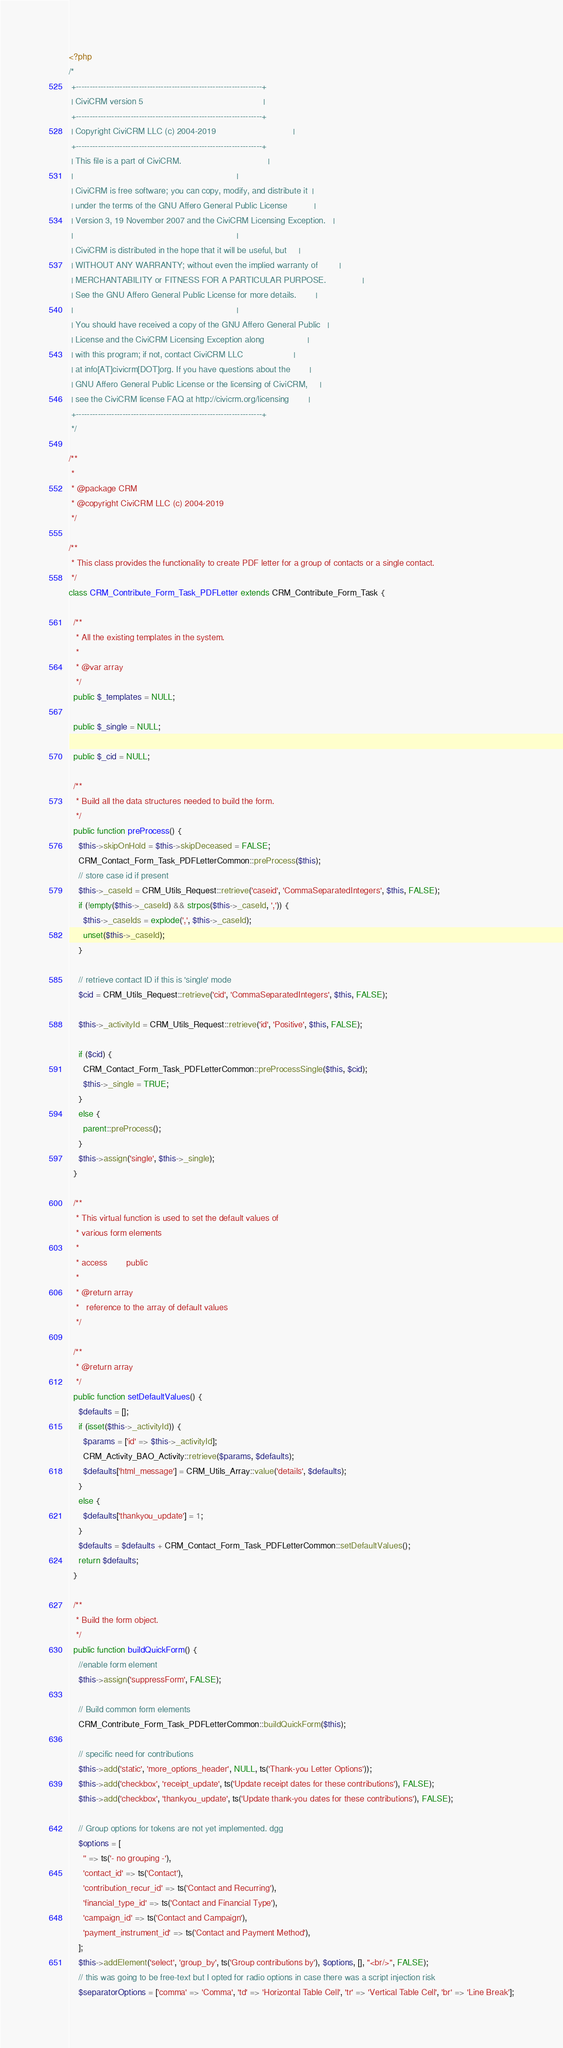<code> <loc_0><loc_0><loc_500><loc_500><_PHP_><?php
/*
 +--------------------------------------------------------------------+
 | CiviCRM version 5                                                  |
 +--------------------------------------------------------------------+
 | Copyright CiviCRM LLC (c) 2004-2019                                |
 +--------------------------------------------------------------------+
 | This file is a part of CiviCRM.                                    |
 |                                                                    |
 | CiviCRM is free software; you can copy, modify, and distribute it  |
 | under the terms of the GNU Affero General Public License           |
 | Version 3, 19 November 2007 and the CiviCRM Licensing Exception.   |
 |                                                                    |
 | CiviCRM is distributed in the hope that it will be useful, but     |
 | WITHOUT ANY WARRANTY; without even the implied warranty of         |
 | MERCHANTABILITY or FITNESS FOR A PARTICULAR PURPOSE.               |
 | See the GNU Affero General Public License for more details.        |
 |                                                                    |
 | You should have received a copy of the GNU Affero General Public   |
 | License and the CiviCRM Licensing Exception along                  |
 | with this program; if not, contact CiviCRM LLC                     |
 | at info[AT]civicrm[DOT]org. If you have questions about the        |
 | GNU Affero General Public License or the licensing of CiviCRM,     |
 | see the CiviCRM license FAQ at http://civicrm.org/licensing        |
 +--------------------------------------------------------------------+
 */

/**
 *
 * @package CRM
 * @copyright CiviCRM LLC (c) 2004-2019
 */

/**
 * This class provides the functionality to create PDF letter for a group of contacts or a single contact.
 */
class CRM_Contribute_Form_Task_PDFLetter extends CRM_Contribute_Form_Task {

  /**
   * All the existing templates in the system.
   *
   * @var array
   */
  public $_templates = NULL;

  public $_single = NULL;

  public $_cid = NULL;

  /**
   * Build all the data structures needed to build the form.
   */
  public function preProcess() {
    $this->skipOnHold = $this->skipDeceased = FALSE;
    CRM_Contact_Form_Task_PDFLetterCommon::preProcess($this);
    // store case id if present
    $this->_caseId = CRM_Utils_Request::retrieve('caseid', 'CommaSeparatedIntegers', $this, FALSE);
    if (!empty($this->_caseId) && strpos($this->_caseId, ',')) {
      $this->_caseIds = explode(',', $this->_caseId);
      unset($this->_caseId);
    }

    // retrieve contact ID if this is 'single' mode
    $cid = CRM_Utils_Request::retrieve('cid', 'CommaSeparatedIntegers', $this, FALSE);

    $this->_activityId = CRM_Utils_Request::retrieve('id', 'Positive', $this, FALSE);

    if ($cid) {
      CRM_Contact_Form_Task_PDFLetterCommon::preProcessSingle($this, $cid);
      $this->_single = TRUE;
    }
    else {
      parent::preProcess();
    }
    $this->assign('single', $this->_single);
  }

  /**
   * This virtual function is used to set the default values of
   * various form elements
   *
   * access        public
   *
   * @return array
   *   reference to the array of default values
   */

  /**
   * @return array
   */
  public function setDefaultValues() {
    $defaults = [];
    if (isset($this->_activityId)) {
      $params = ['id' => $this->_activityId];
      CRM_Activity_BAO_Activity::retrieve($params, $defaults);
      $defaults['html_message'] = CRM_Utils_Array::value('details', $defaults);
    }
    else {
      $defaults['thankyou_update'] = 1;
    }
    $defaults = $defaults + CRM_Contact_Form_Task_PDFLetterCommon::setDefaultValues();
    return $defaults;
  }

  /**
   * Build the form object.
   */
  public function buildQuickForm() {
    //enable form element
    $this->assign('suppressForm', FALSE);

    // Build common form elements
    CRM_Contribute_Form_Task_PDFLetterCommon::buildQuickForm($this);

    // specific need for contributions
    $this->add('static', 'more_options_header', NULL, ts('Thank-you Letter Options'));
    $this->add('checkbox', 'receipt_update', ts('Update receipt dates for these contributions'), FALSE);
    $this->add('checkbox', 'thankyou_update', ts('Update thank-you dates for these contributions'), FALSE);

    // Group options for tokens are not yet implemented. dgg
    $options = [
      '' => ts('- no grouping -'),
      'contact_id' => ts('Contact'),
      'contribution_recur_id' => ts('Contact and Recurring'),
      'financial_type_id' => ts('Contact and Financial Type'),
      'campaign_id' => ts('Contact and Campaign'),
      'payment_instrument_id' => ts('Contact and Payment Method'),
    ];
    $this->addElement('select', 'group_by', ts('Group contributions by'), $options, [], "<br/>", FALSE);
    // this was going to be free-text but I opted for radio options in case there was a script injection risk
    $separatorOptions = ['comma' => 'Comma', 'td' => 'Horizontal Table Cell', 'tr' => 'Vertical Table Cell', 'br' => 'Line Break'];
</code> 